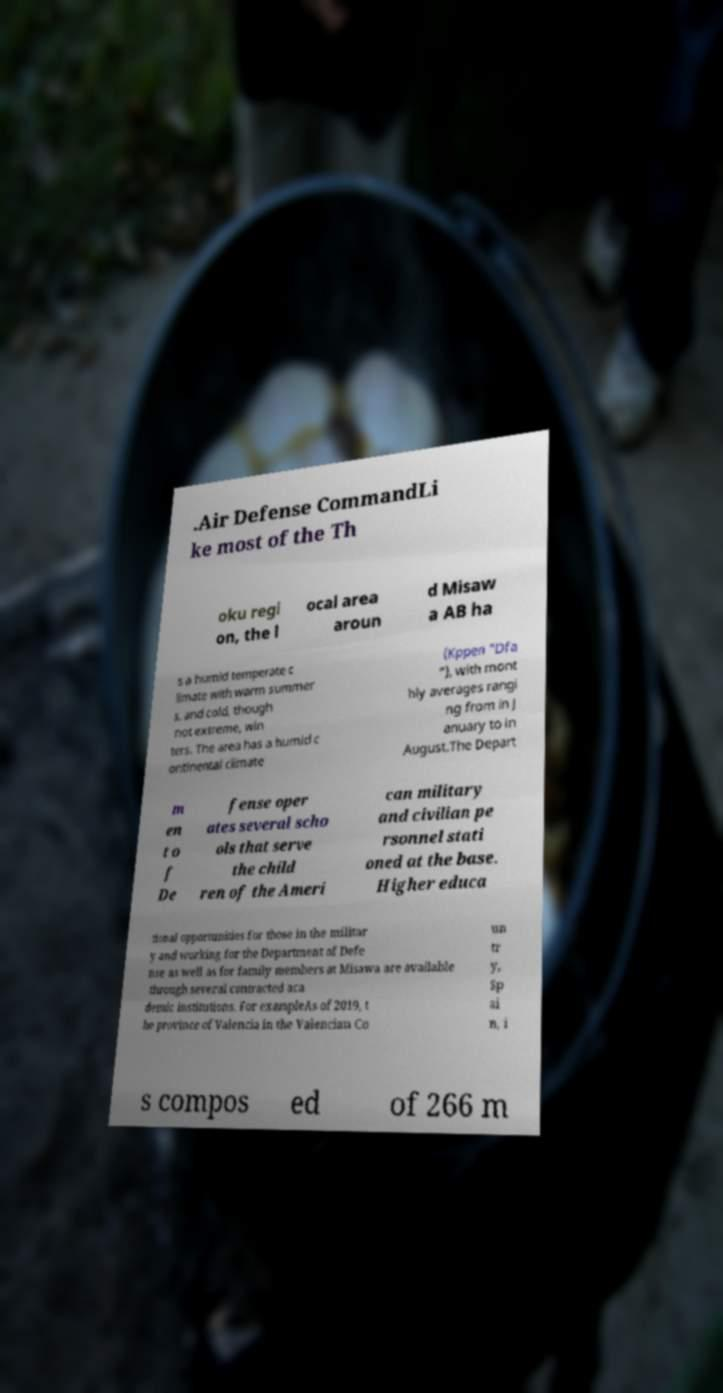Can you read and provide the text displayed in the image?This photo seems to have some interesting text. Can you extract and type it out for me? .Air Defense CommandLi ke most of the Th oku regi on, the l ocal area aroun d Misaw a AB ha s a humid temperate c limate with warm summer s, and cold, though not extreme, win ters. The area has a humid c ontinental climate (Kppen "Dfa "), with mont hly averages rangi ng from in J anuary to in August.The Depart m en t o f De fense oper ates several scho ols that serve the child ren of the Ameri can military and civilian pe rsonnel stati oned at the base. Higher educa tional opportunities for those in the militar y and working for the Department of Defe nse as well as for family members at Misawa are available through several contracted aca demic institutions. For exampleAs of 2019, t he province of Valencia in the Valencian Co un tr y, Sp ai n, i s compos ed of 266 m 